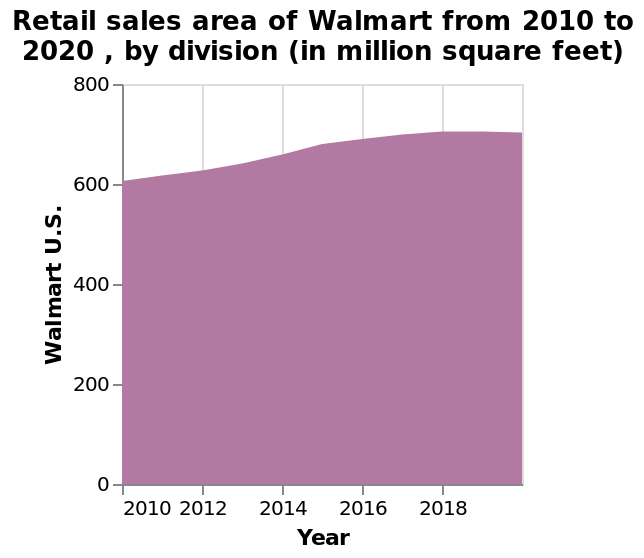<image>
What is being plotted on the y-axis? The y-axis plots the retail sales area of Walmart U.S. in million square feet. How would you describe the direction of retail sales from 2010 to 2020?  The direction of retail sales from 2010 to 2020 is upward, indicating an overall increase. Is the trend of retail sales from 2010 to 2020 generally increasing?  Yes, the trend of retail sales from 2010 to 2020 is generally increasing. 